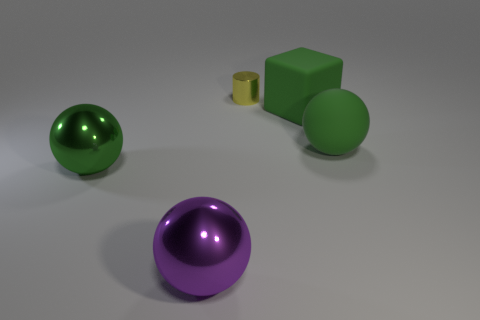How many green balls must be subtracted to get 1 green balls? 1 Subtract all large purple metallic spheres. How many spheres are left? 2 Add 5 green metallic balls. How many objects exist? 10 Subtract all green balls. How many balls are left? 1 Subtract all brown cylinders. How many green balls are left? 2 Subtract all large shiny objects. Subtract all yellow things. How many objects are left? 2 Add 4 big matte blocks. How many big matte blocks are left? 5 Add 4 big gray cubes. How many big gray cubes exist? 4 Subtract 0 purple cylinders. How many objects are left? 5 Subtract all spheres. How many objects are left? 2 